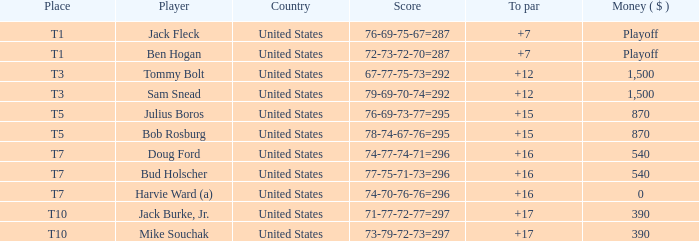Which money has player Jack Fleck with t1 place? Playoff. 